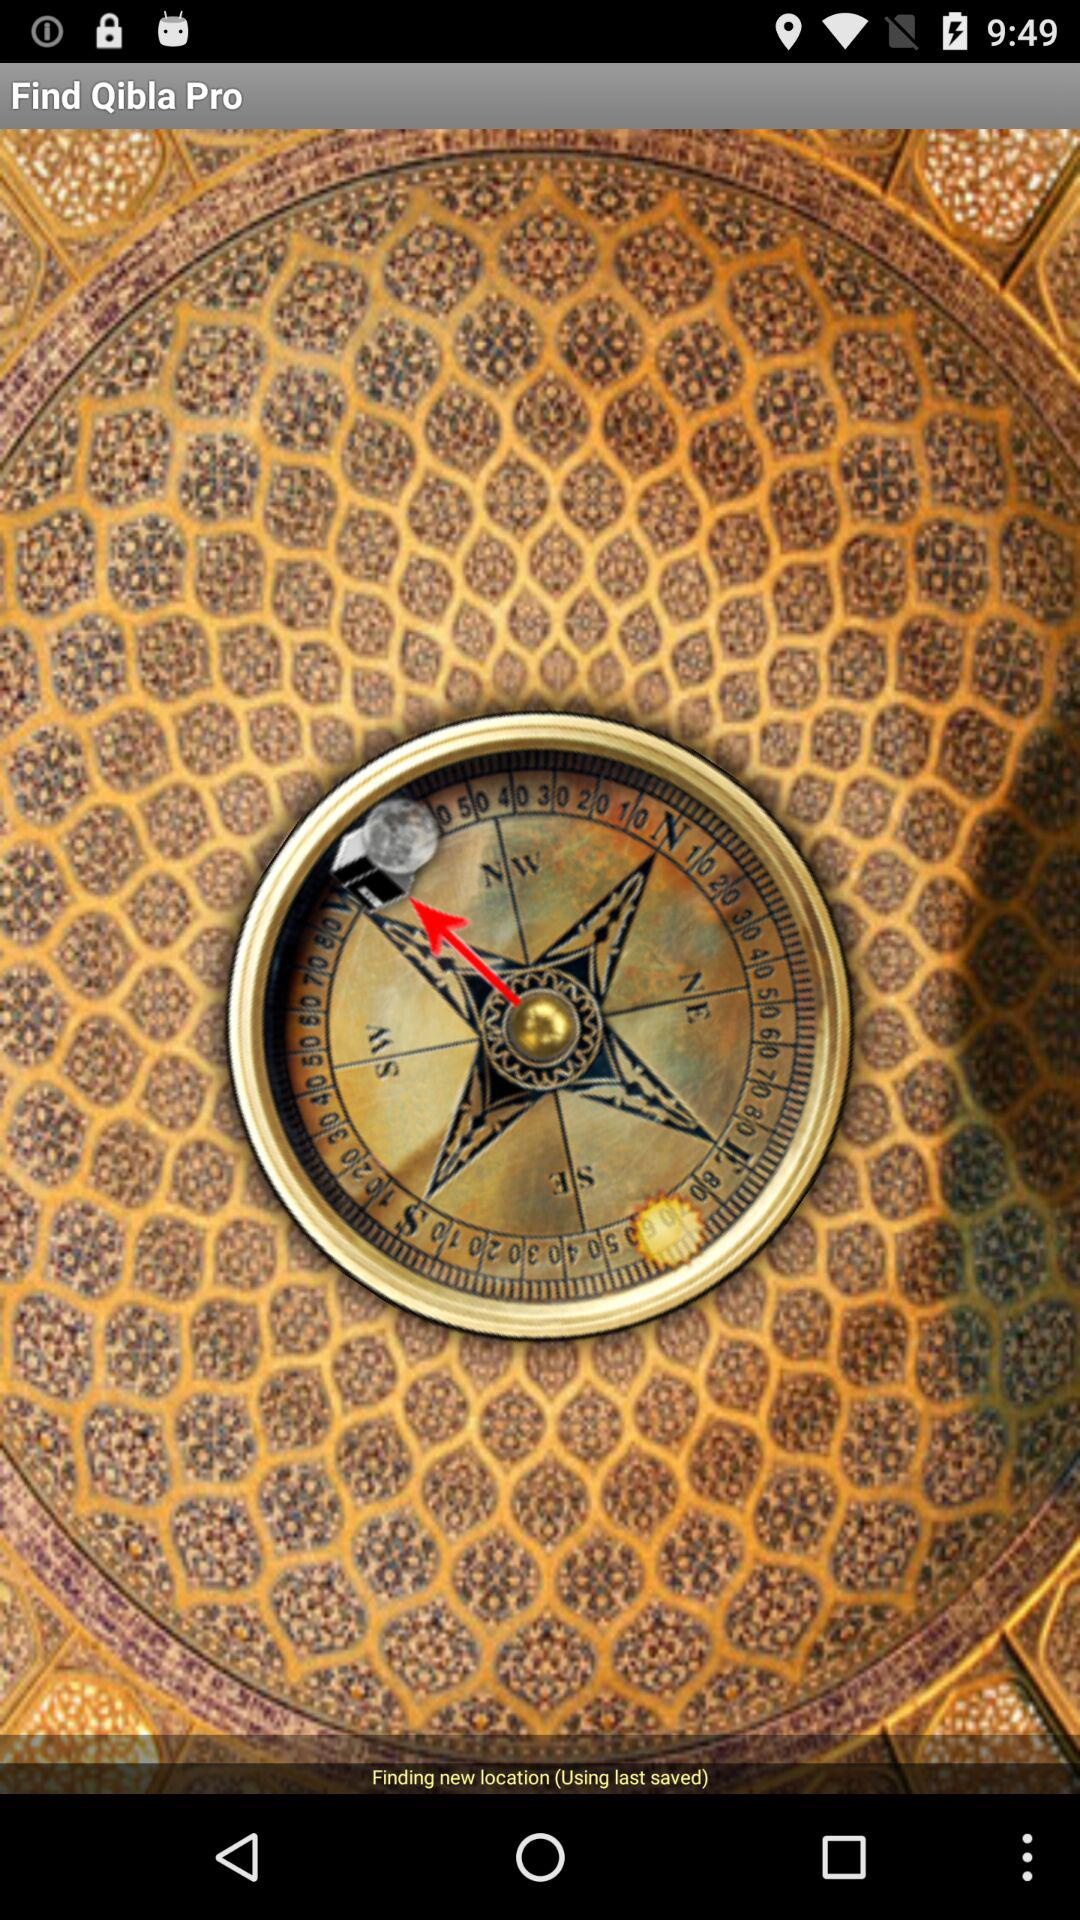What is the name of the application? The name of the application is "Qibla Pro". 